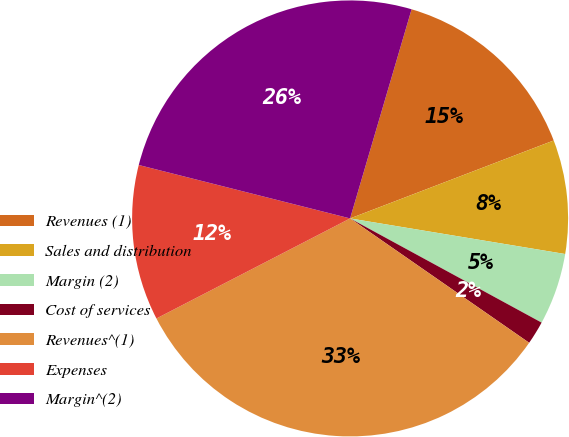Convert chart to OTSL. <chart><loc_0><loc_0><loc_500><loc_500><pie_chart><fcel>Revenues (1)<fcel>Sales and distribution<fcel>Margin (2)<fcel>Cost of services<fcel>Revenues^(1)<fcel>Expenses<fcel>Margin^(2)<nl><fcel>14.63%<fcel>8.43%<fcel>5.32%<fcel>1.73%<fcel>32.75%<fcel>11.53%<fcel>25.61%<nl></chart> 